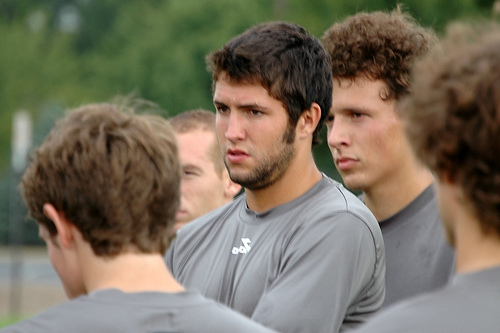<image>
Is there a boy to the left of the boy? Yes. From this viewpoint, the boy is positioned to the left side relative to the boy. 